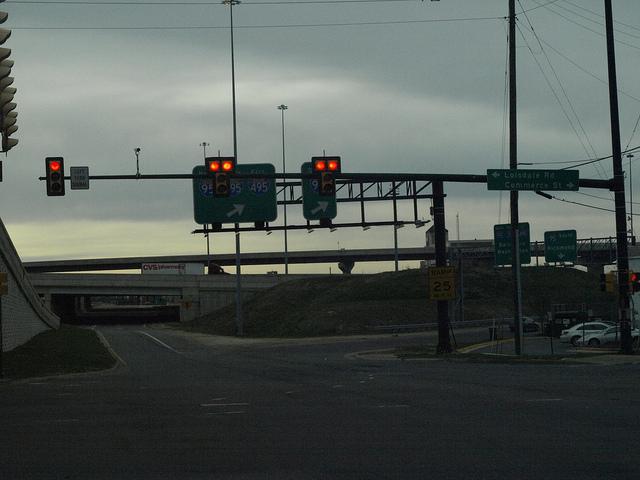Can you make a right turn?
Quick response, please. Yes. What is in the background?
Give a very brief answer. Bridge. Is it daytime?
Quick response, please. Yes. What color is on the traffic light?
Be succinct. Red. What color is the traffic signal?
Keep it brief. Red. How many red lights are there?
Write a very short answer. 5. What color are the traffic lights seen here?
Write a very short answer. Red. Is this a busy thoroughfare?
Concise answer only. No. When this sort of traffic item is not saying go or stop what is it saying?
Keep it brief. Yield. Is it cloudy outside?
Concise answer only. Yes. What is the color of the bridge?
Give a very brief answer. Gray. What color are the stop lights?
Be succinct. Red. How cold is it?
Quick response, please. Mild. Can you turn left at this intersection?
Short answer required. Yes. What color is the light against the sky?
Short answer required. Red. Can you purchase a car nearby?
Short answer required. No. 